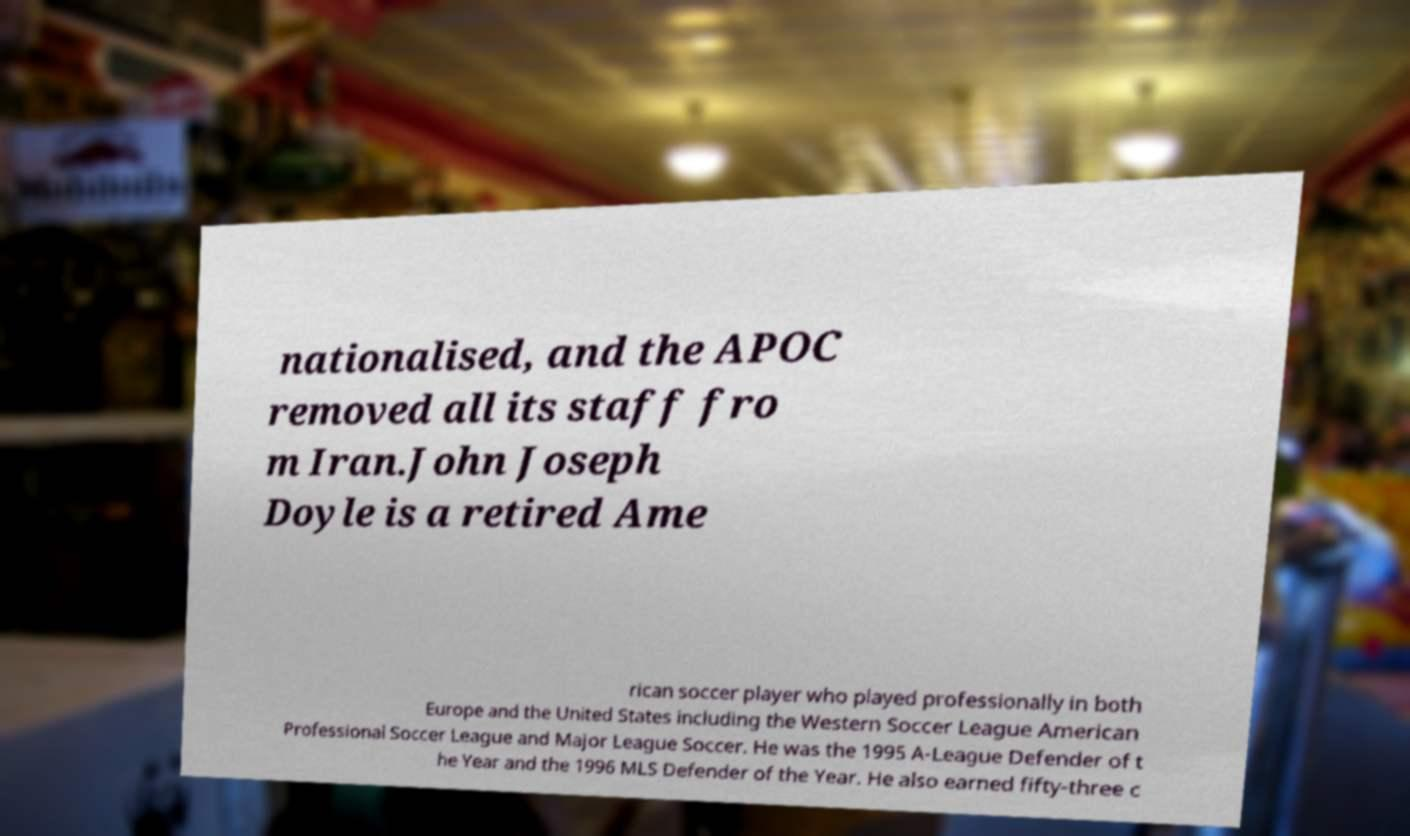Please identify and transcribe the text found in this image. nationalised, and the APOC removed all its staff fro m Iran.John Joseph Doyle is a retired Ame rican soccer player who played professionally in both Europe and the United States including the Western Soccer League American Professional Soccer League and Major League Soccer. He was the 1995 A-League Defender of t he Year and the 1996 MLS Defender of the Year. He also earned fifty-three c 